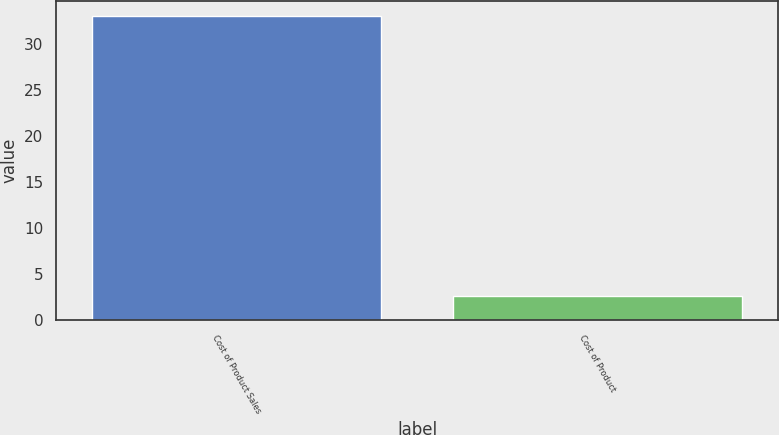Convert chart to OTSL. <chart><loc_0><loc_0><loc_500><loc_500><bar_chart><fcel>Cost of Product Sales<fcel>Cost of Product<nl><fcel>33<fcel>2.69<nl></chart> 